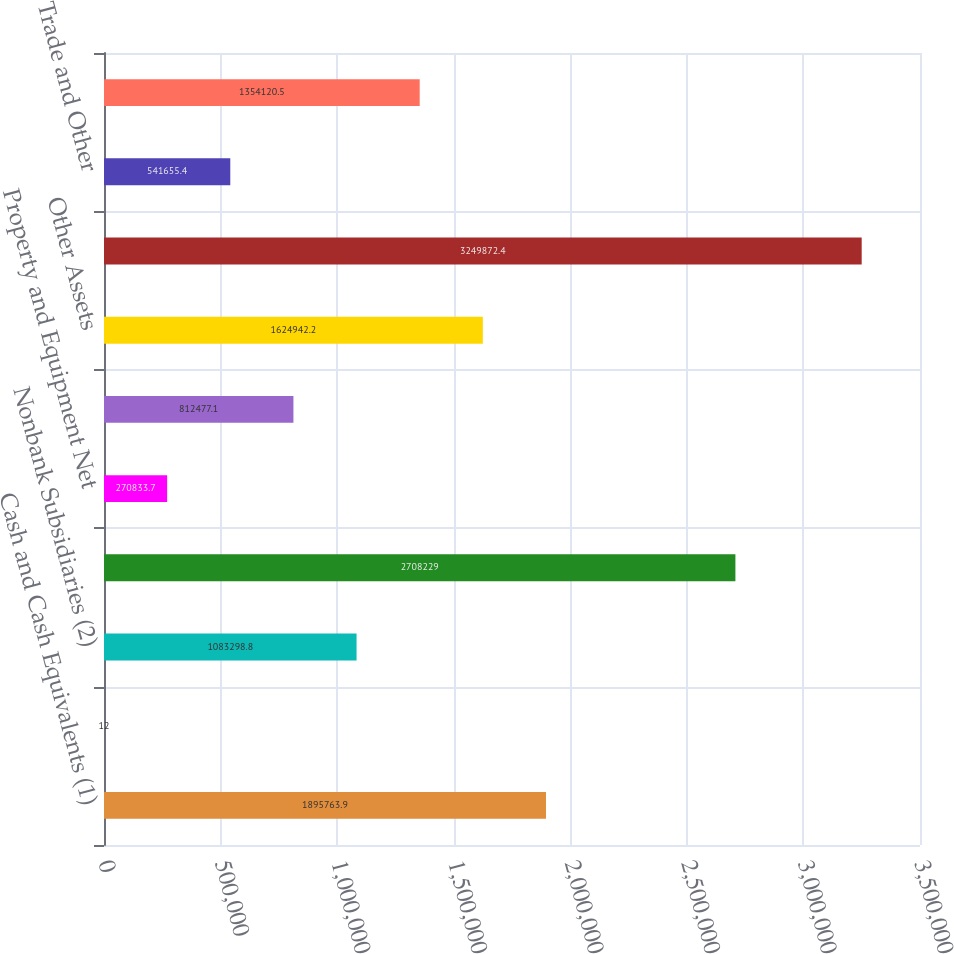Convert chart to OTSL. <chart><loc_0><loc_0><loc_500><loc_500><bar_chart><fcel>Cash and Cash Equivalents (1)<fcel>Bank Subsidiary<fcel>Nonbank Subsidiaries (2)<fcel>Nonbank Subsidiaries<fcel>Property and Equipment Net<fcel>Goodwill<fcel>Other Assets<fcel>Total Assets<fcel>Trade and Other<fcel>Accrued Compensation and<nl><fcel>1.89576e+06<fcel>12<fcel>1.0833e+06<fcel>2.70823e+06<fcel>270834<fcel>812477<fcel>1.62494e+06<fcel>3.24987e+06<fcel>541655<fcel>1.35412e+06<nl></chart> 